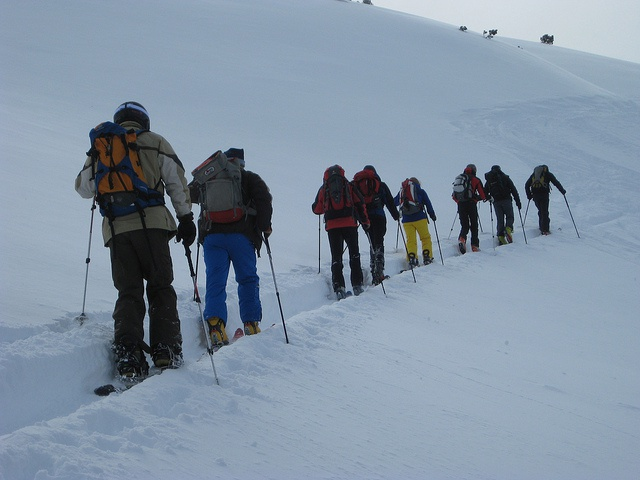Describe the objects in this image and their specific colors. I can see people in darkgray, black, and purple tones, people in darkgray, navy, black, and gray tones, backpack in darkgray, black, maroon, navy, and blue tones, people in darkgray, black, maroon, and gray tones, and backpack in darkgray, black, purple, and gray tones in this image. 